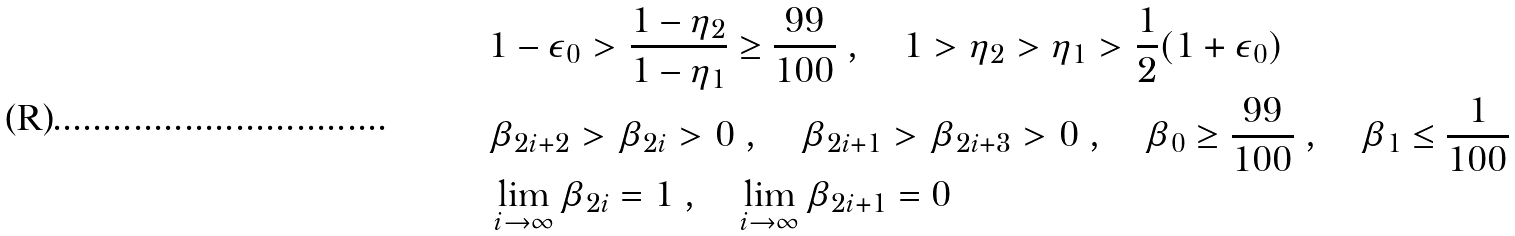<formula> <loc_0><loc_0><loc_500><loc_500>& 1 - \epsilon _ { 0 } > \frac { 1 - \eta _ { 2 } } { 1 - \eta _ { 1 } } \geq \frac { 9 9 } { 1 0 0 } \ , \quad 1 > \eta _ { 2 } > \eta _ { 1 } > \frac { 1 } { 2 } ( 1 + \epsilon _ { 0 } ) \\ & \beta _ { 2 i + 2 } > \beta _ { 2 i } > 0 \ , \quad \beta _ { 2 i + 1 } > \beta _ { 2 i + 3 } > 0 \ , \quad \beta _ { 0 } \geq \frac { 9 9 } { 1 0 0 } \ , \quad \beta _ { 1 } \leq \frac { 1 } { 1 0 0 } \\ & \lim _ { i \rightarrow \infty } \beta _ { 2 i } = 1 \ , \quad \lim _ { i \rightarrow \infty } \beta _ { 2 i + 1 } = 0</formula> 